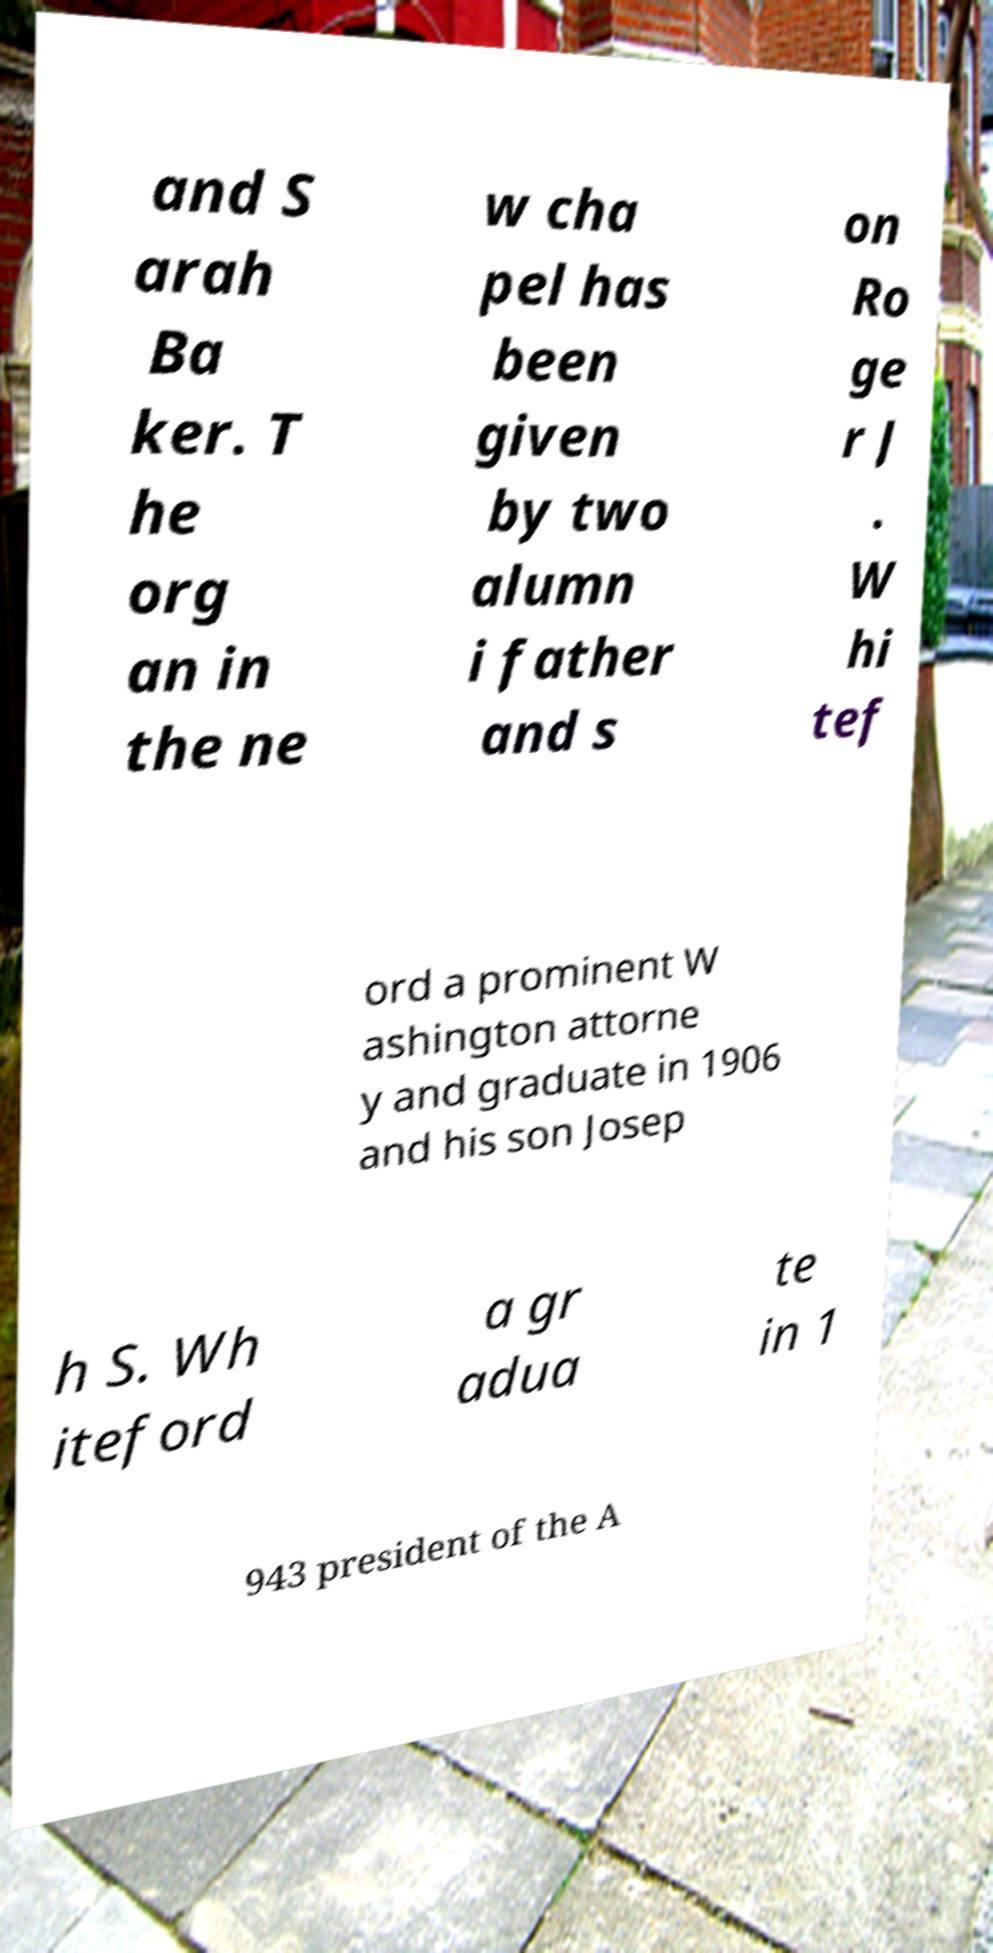I need the written content from this picture converted into text. Can you do that? and S arah Ba ker. T he org an in the ne w cha pel has been given by two alumn i father and s on Ro ge r J . W hi tef ord a prominent W ashington attorne y and graduate in 1906 and his son Josep h S. Wh iteford a gr adua te in 1 943 president of the A 